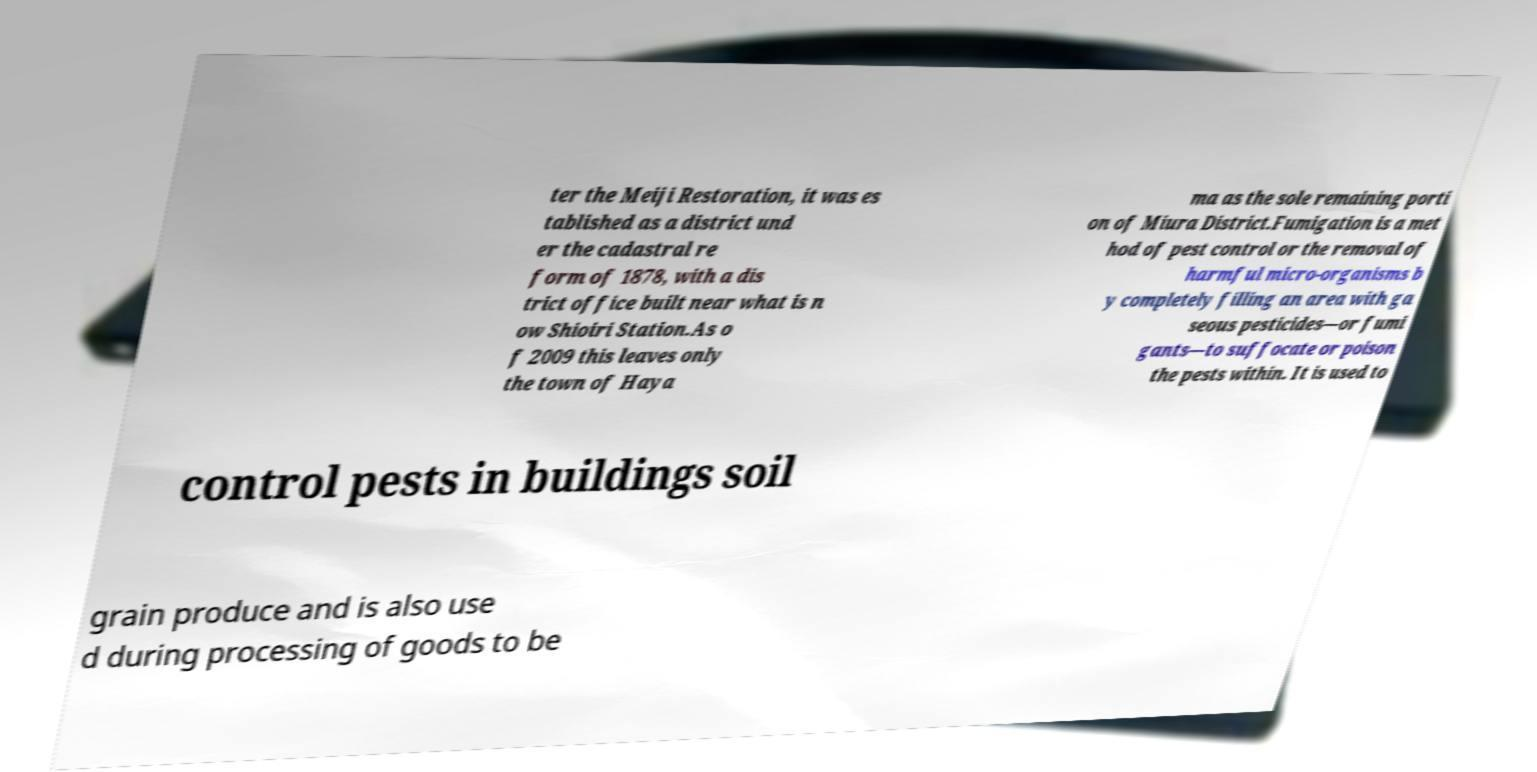There's text embedded in this image that I need extracted. Can you transcribe it verbatim? ter the Meiji Restoration, it was es tablished as a district und er the cadastral re form of 1878, with a dis trict office built near what is n ow Shioiri Station.As o f 2009 this leaves only the town of Haya ma as the sole remaining porti on of Miura District.Fumigation is a met hod of pest control or the removal of harmful micro-organisms b y completely filling an area with ga seous pesticides—or fumi gants—to suffocate or poison the pests within. It is used to control pests in buildings soil grain produce and is also use d during processing of goods to be 